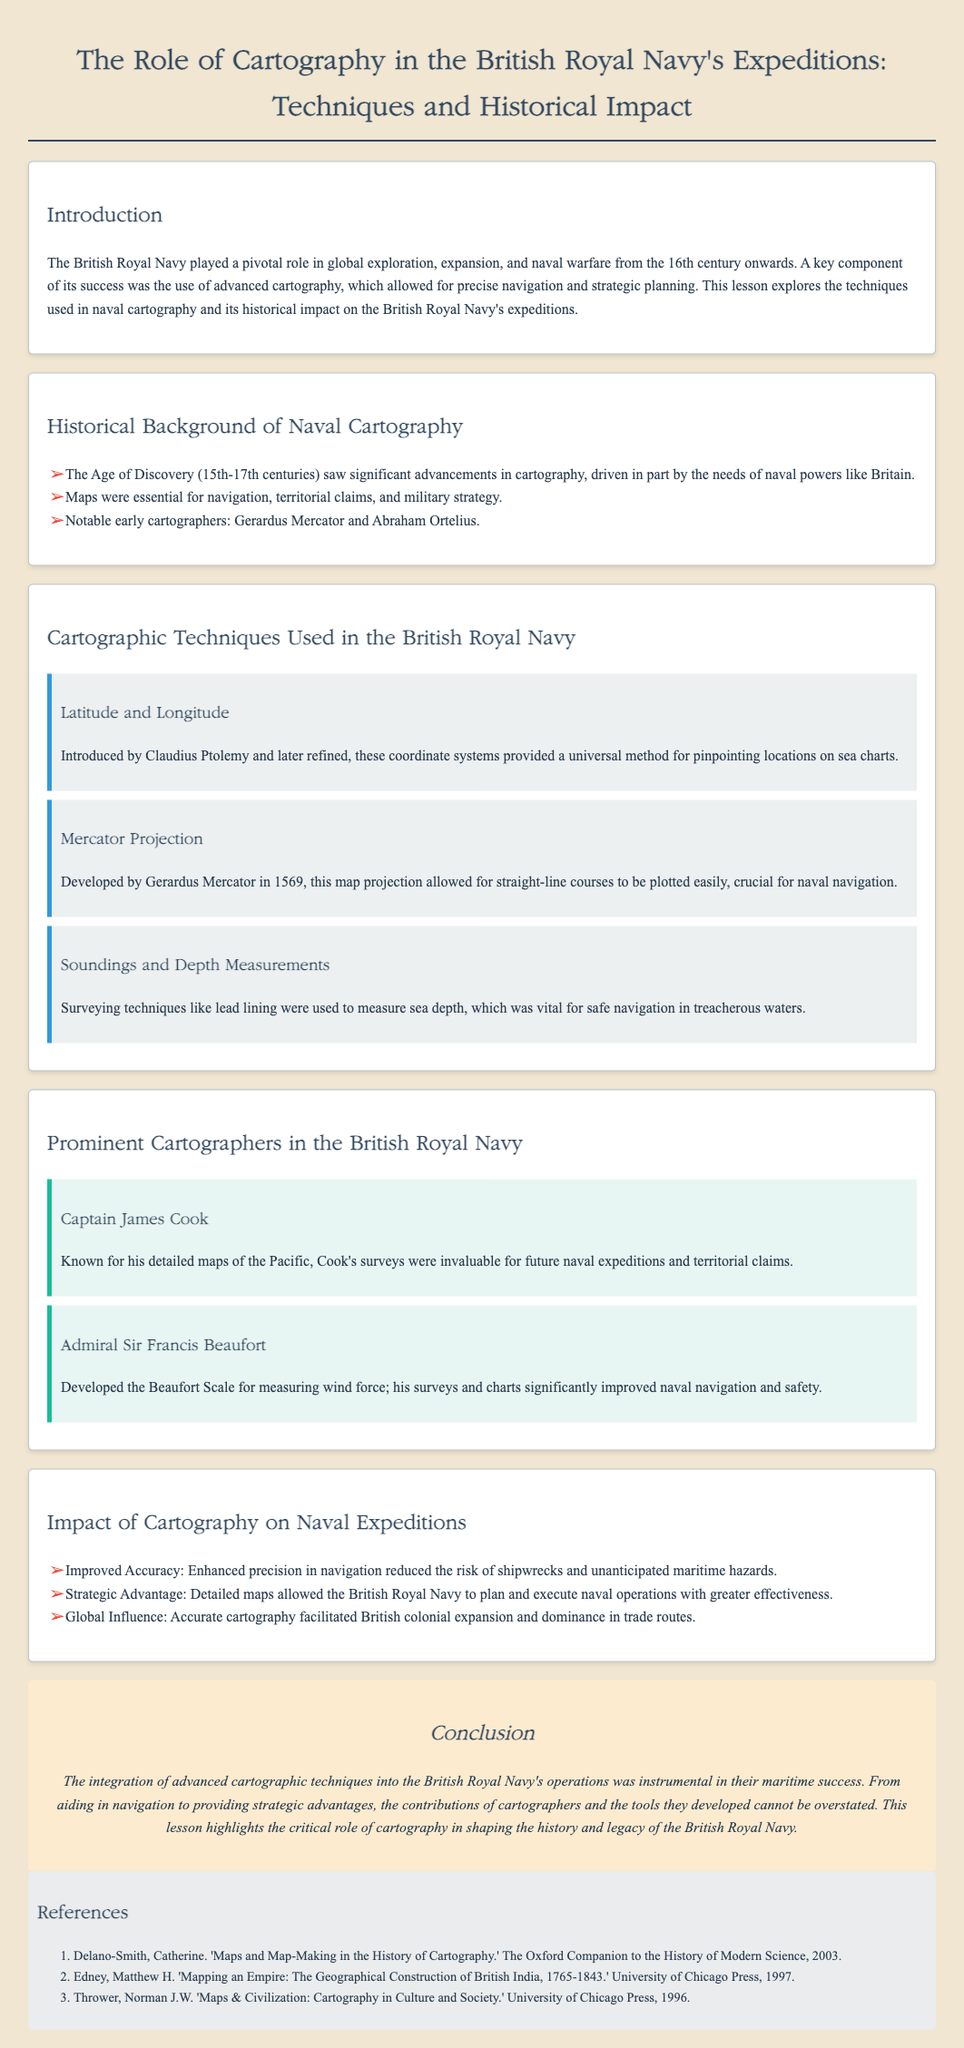What were the notable early cartographers mentioned? The document lists notable early cartographers such as Gerardus Mercator and Abraham Ortelius.
Answer: Gerardus Mercator and Abraham Ortelius Who developed the Mercator Projection? The document states that the Mercator Projection was developed by Gerardus Mercator in 1569.
Answer: Gerardus Mercator What technique did Captain James Cook improve that was vital for naval expeditions? According to the document, Captain James Cook's detailed maps were invaluable for future naval expeditions.
Answer: Detailed maps What impact did improved accuracy in navigation have on naval expeditions? The text explains that improved accuracy reduced the risk of shipwrecks and unanticipated maritime hazards.
Answer: Reduced the risk of shipwrecks How many prominent cartographers are listed in the document? The document mentions two prominent cartographers: Captain James Cook and Admiral Sir Francis Beaufort.
Answer: Two What was one of the key roles of the British Royal Navy highlighted in the introduction? The introduction states that the British Royal Navy played a pivotal role in global exploration, expansion, and naval warfare.
Answer: Global exploration What does the Beaufort Scale measure? The document mentions that Admiral Sir Francis Beaufort developed the Beaufort Scale for measuring wind force.
Answer: Wind force What technological advancement in cartography is mentioned as crucial for naval navigation? The text mentions the Mercator Projection as a significant advancement crucial for naval navigation.
Answer: Mercator Projection 